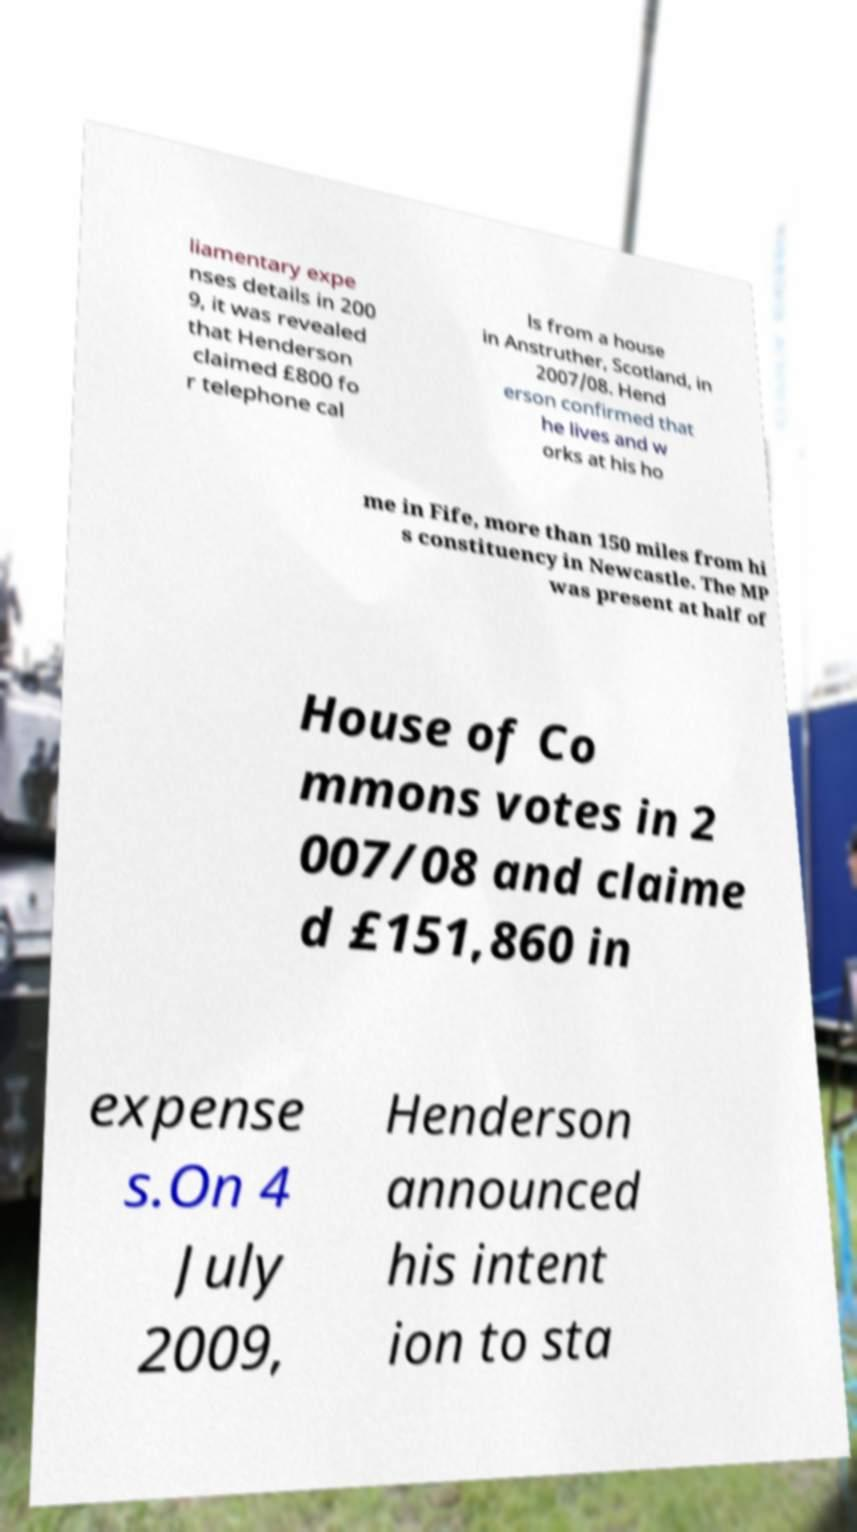For documentation purposes, I need the text within this image transcribed. Could you provide that? liamentary expe nses details in 200 9, it was revealed that Henderson claimed £800 fo r telephone cal ls from a house in Anstruther, Scotland, in 2007/08. Hend erson confirmed that he lives and w orks at his ho me in Fife, more than 150 miles from hi s constituency in Newcastle. The MP was present at half of House of Co mmons votes in 2 007/08 and claime d £151,860 in expense s.On 4 July 2009, Henderson announced his intent ion to sta 